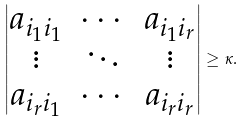<formula> <loc_0><loc_0><loc_500><loc_500>\begin{vmatrix} a _ { i _ { 1 } i _ { 1 } } & \cdots & a _ { i _ { 1 } i _ { r } } \\ \vdots & \ddots & \vdots \\ a _ { i _ { r } i _ { 1 } } & \cdots & a _ { i _ { r } i _ { r } } \end{vmatrix} \geq \kappa .</formula> 